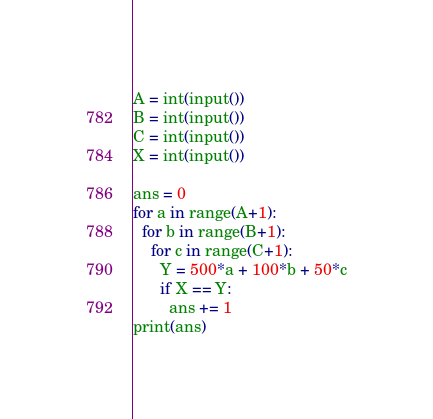<code> <loc_0><loc_0><loc_500><loc_500><_Python_>A = int(input())
B = int(input())
C = int(input())
X = int(input())

ans = 0
for a in range(A+1):
  for b in range(B+1):
    for c in range(C+1):
      Y = 500*a + 100*b + 50*c
      if X == Y:
        ans += 1
print(ans)
</code> 